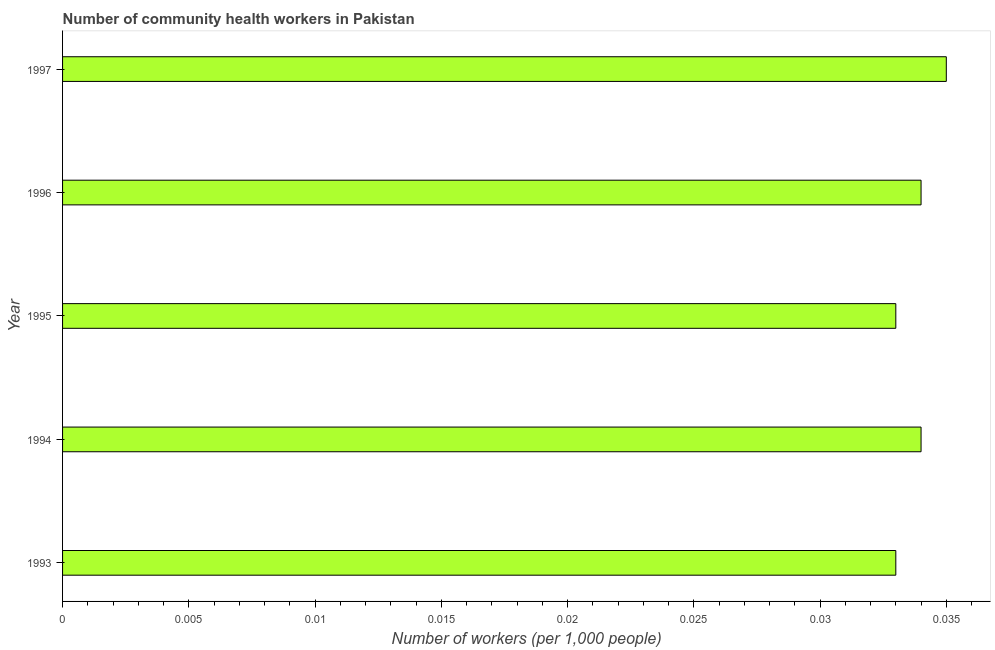Does the graph contain grids?
Give a very brief answer. No. What is the title of the graph?
Provide a succinct answer. Number of community health workers in Pakistan. What is the label or title of the X-axis?
Make the answer very short. Number of workers (per 1,0 people). What is the number of community health workers in 1993?
Give a very brief answer. 0.03. Across all years, what is the maximum number of community health workers?
Ensure brevity in your answer.  0.04. Across all years, what is the minimum number of community health workers?
Ensure brevity in your answer.  0.03. In which year was the number of community health workers minimum?
Your response must be concise. 1993. What is the sum of the number of community health workers?
Keep it short and to the point. 0.17. What is the difference between the number of community health workers in 1993 and 1995?
Your response must be concise. 0. What is the average number of community health workers per year?
Offer a terse response. 0.03. What is the median number of community health workers?
Offer a terse response. 0.03. Do a majority of the years between 1993 and 1995 (inclusive) have number of community health workers greater than 0.034 ?
Provide a succinct answer. No. What is the ratio of the number of community health workers in 1995 to that in 1997?
Ensure brevity in your answer.  0.94. Is the number of community health workers in 1993 less than that in 1995?
Ensure brevity in your answer.  No. Is the sum of the number of community health workers in 1993 and 1994 greater than the maximum number of community health workers across all years?
Keep it short and to the point. Yes. What is the difference between the highest and the lowest number of community health workers?
Give a very brief answer. 0. How many bars are there?
Make the answer very short. 5. Are all the bars in the graph horizontal?
Offer a terse response. Yes. How many years are there in the graph?
Keep it short and to the point. 5. What is the difference between two consecutive major ticks on the X-axis?
Give a very brief answer. 0.01. Are the values on the major ticks of X-axis written in scientific E-notation?
Make the answer very short. No. What is the Number of workers (per 1,000 people) in 1993?
Ensure brevity in your answer.  0.03. What is the Number of workers (per 1,000 people) in 1994?
Provide a short and direct response. 0.03. What is the Number of workers (per 1,000 people) in 1995?
Give a very brief answer. 0.03. What is the Number of workers (per 1,000 people) of 1996?
Ensure brevity in your answer.  0.03. What is the Number of workers (per 1,000 people) of 1997?
Provide a short and direct response. 0.04. What is the difference between the Number of workers (per 1,000 people) in 1993 and 1994?
Give a very brief answer. -0. What is the difference between the Number of workers (per 1,000 people) in 1993 and 1995?
Offer a terse response. 0. What is the difference between the Number of workers (per 1,000 people) in 1993 and 1996?
Your response must be concise. -0. What is the difference between the Number of workers (per 1,000 people) in 1993 and 1997?
Offer a very short reply. -0. What is the difference between the Number of workers (per 1,000 people) in 1994 and 1996?
Your answer should be compact. 0. What is the difference between the Number of workers (per 1,000 people) in 1994 and 1997?
Give a very brief answer. -0. What is the difference between the Number of workers (per 1,000 people) in 1995 and 1996?
Your answer should be compact. -0. What is the difference between the Number of workers (per 1,000 people) in 1995 and 1997?
Provide a succinct answer. -0. What is the difference between the Number of workers (per 1,000 people) in 1996 and 1997?
Provide a succinct answer. -0. What is the ratio of the Number of workers (per 1,000 people) in 1993 to that in 1996?
Provide a short and direct response. 0.97. What is the ratio of the Number of workers (per 1,000 people) in 1993 to that in 1997?
Give a very brief answer. 0.94. What is the ratio of the Number of workers (per 1,000 people) in 1994 to that in 1995?
Your answer should be compact. 1.03. What is the ratio of the Number of workers (per 1,000 people) in 1994 to that in 1996?
Offer a very short reply. 1. What is the ratio of the Number of workers (per 1,000 people) in 1994 to that in 1997?
Offer a terse response. 0.97. What is the ratio of the Number of workers (per 1,000 people) in 1995 to that in 1996?
Provide a succinct answer. 0.97. What is the ratio of the Number of workers (per 1,000 people) in 1995 to that in 1997?
Keep it short and to the point. 0.94. 